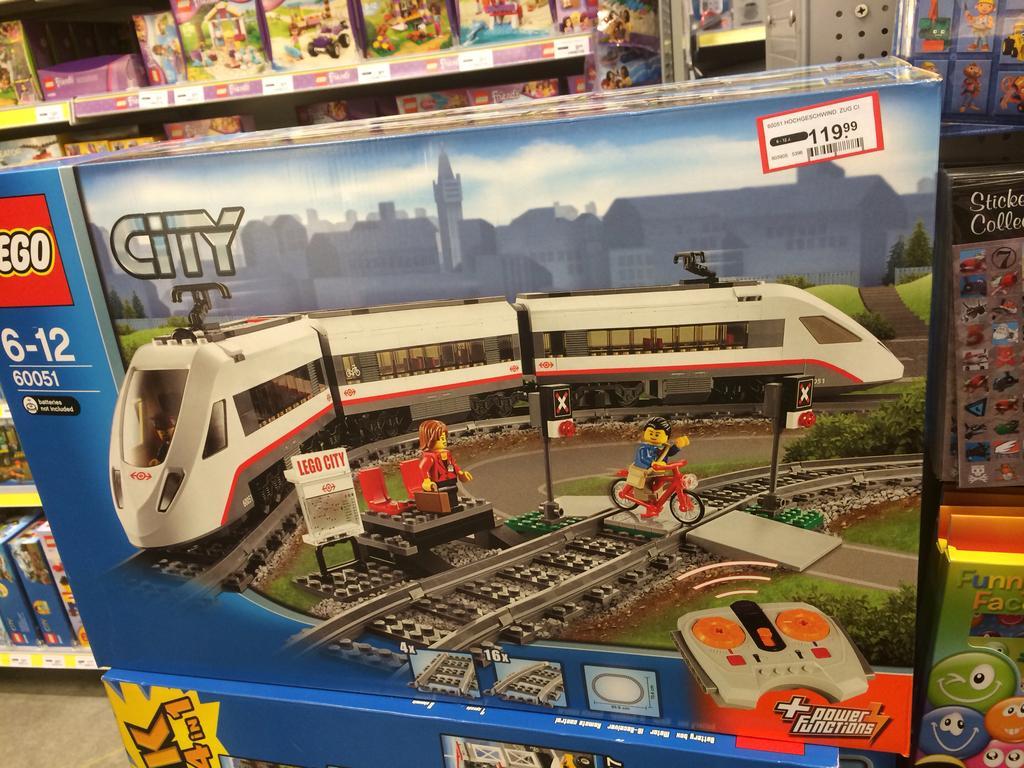Could you give a brief overview of what you see in this image? In this image we can see some boxes placed on the surface containing the pictures of some toys and text on it. On the backside we can see a group of boxes placed in the shelves. 